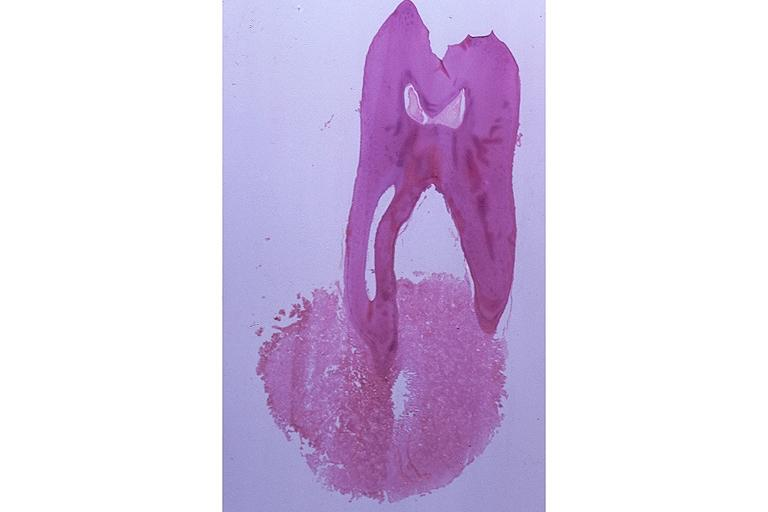does this image show cementoblastoma?
Answer the question using a single word or phrase. Yes 